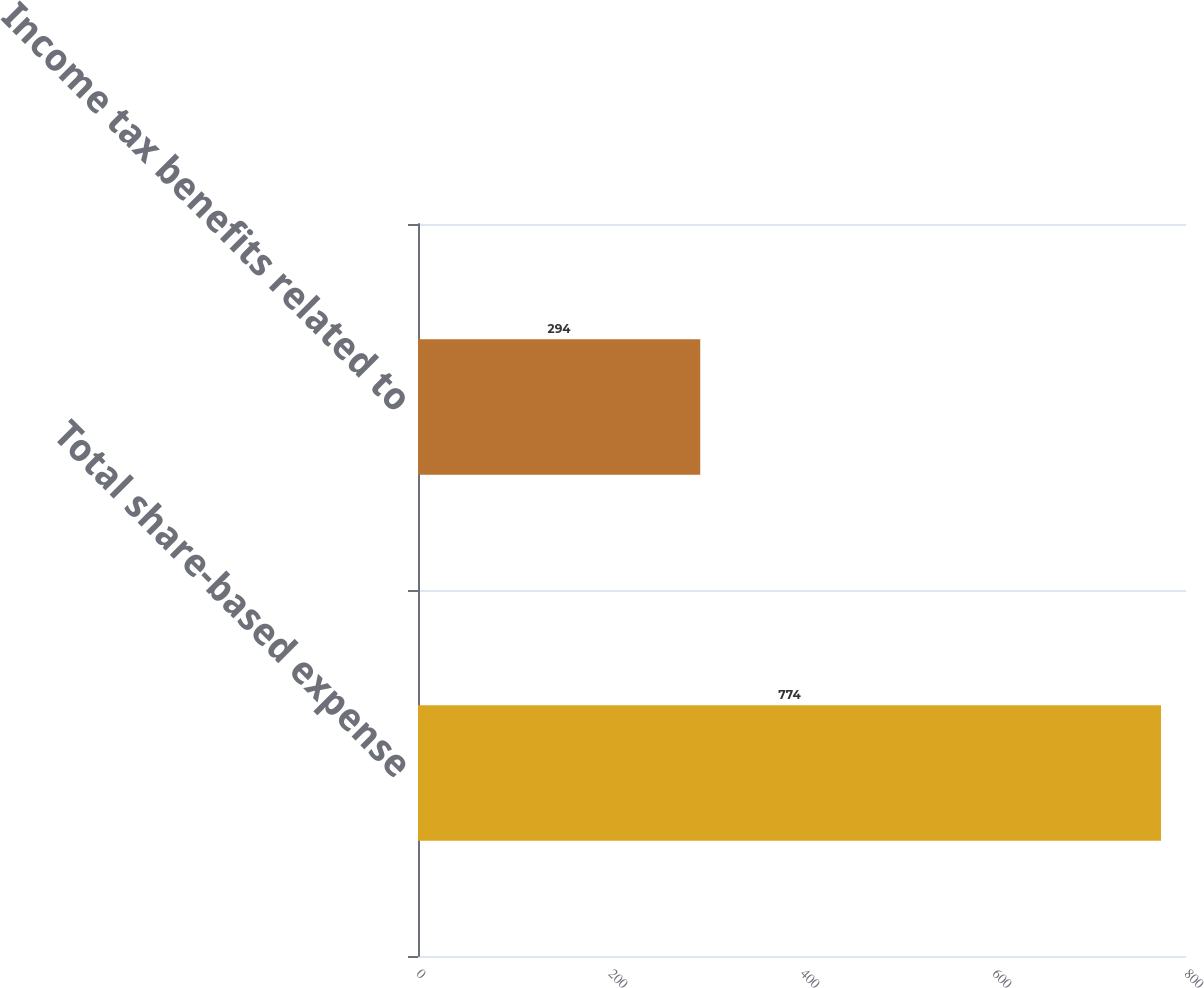Convert chart. <chart><loc_0><loc_0><loc_500><loc_500><bar_chart><fcel>Total share-based expense<fcel>Income tax benefits related to<nl><fcel>774<fcel>294<nl></chart> 